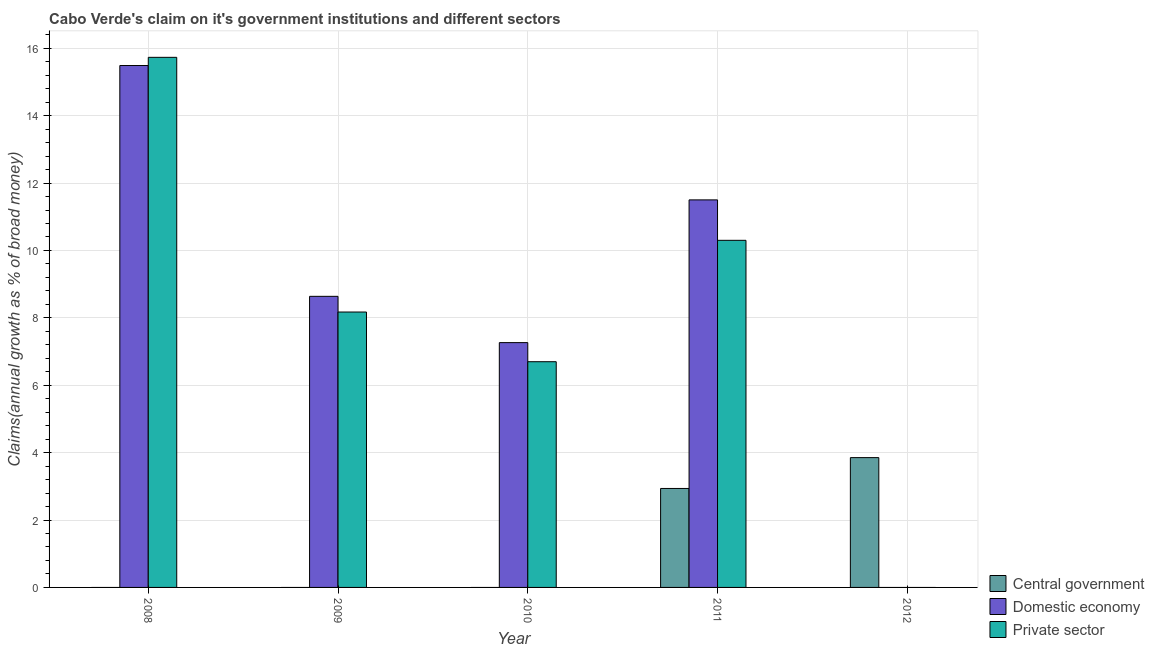Are the number of bars on each tick of the X-axis equal?
Offer a terse response. No. What is the label of the 5th group of bars from the left?
Offer a very short reply. 2012. In how many cases, is the number of bars for a given year not equal to the number of legend labels?
Provide a succinct answer. 4. Across all years, what is the maximum percentage of claim on the central government?
Your answer should be very brief. 3.85. What is the total percentage of claim on the domestic economy in the graph?
Your answer should be compact. 42.89. What is the difference between the percentage of claim on the domestic economy in 2008 and that in 2009?
Your answer should be compact. 6.85. What is the difference between the percentage of claim on the domestic economy in 2010 and the percentage of claim on the private sector in 2008?
Your response must be concise. -8.22. What is the average percentage of claim on the private sector per year?
Give a very brief answer. 8.18. In the year 2008, what is the difference between the percentage of claim on the domestic economy and percentage of claim on the central government?
Offer a terse response. 0. In how many years, is the percentage of claim on the central government greater than 12 %?
Your answer should be compact. 0. Is the percentage of claim on the private sector in 2008 less than that in 2010?
Provide a short and direct response. No. Is the difference between the percentage of claim on the private sector in 2009 and 2011 greater than the difference between the percentage of claim on the central government in 2009 and 2011?
Your response must be concise. No. What is the difference between the highest and the second highest percentage of claim on the private sector?
Offer a terse response. 5.43. What is the difference between the highest and the lowest percentage of claim on the central government?
Offer a very short reply. 3.85. Is the sum of the percentage of claim on the domestic economy in 2009 and 2010 greater than the maximum percentage of claim on the private sector across all years?
Ensure brevity in your answer.  Yes. Is it the case that in every year, the sum of the percentage of claim on the central government and percentage of claim on the domestic economy is greater than the percentage of claim on the private sector?
Offer a terse response. No. Are all the bars in the graph horizontal?
Give a very brief answer. No. What is the difference between two consecutive major ticks on the Y-axis?
Offer a terse response. 2. Does the graph contain any zero values?
Provide a succinct answer. Yes. Does the graph contain grids?
Ensure brevity in your answer.  Yes. Where does the legend appear in the graph?
Offer a terse response. Bottom right. How many legend labels are there?
Keep it short and to the point. 3. What is the title of the graph?
Keep it short and to the point. Cabo Verde's claim on it's government institutions and different sectors. What is the label or title of the X-axis?
Your response must be concise. Year. What is the label or title of the Y-axis?
Keep it short and to the point. Claims(annual growth as % of broad money). What is the Claims(annual growth as % of broad money) in Central government in 2008?
Make the answer very short. 0. What is the Claims(annual growth as % of broad money) of Domestic economy in 2008?
Keep it short and to the point. 15.49. What is the Claims(annual growth as % of broad money) in Private sector in 2008?
Keep it short and to the point. 15.73. What is the Claims(annual growth as % of broad money) in Central government in 2009?
Provide a succinct answer. 0. What is the Claims(annual growth as % of broad money) in Domestic economy in 2009?
Make the answer very short. 8.64. What is the Claims(annual growth as % of broad money) in Private sector in 2009?
Ensure brevity in your answer.  8.17. What is the Claims(annual growth as % of broad money) of Domestic economy in 2010?
Provide a short and direct response. 7.26. What is the Claims(annual growth as % of broad money) of Private sector in 2010?
Your response must be concise. 6.7. What is the Claims(annual growth as % of broad money) in Central government in 2011?
Make the answer very short. 2.94. What is the Claims(annual growth as % of broad money) of Domestic economy in 2011?
Make the answer very short. 11.5. What is the Claims(annual growth as % of broad money) in Private sector in 2011?
Offer a very short reply. 10.3. What is the Claims(annual growth as % of broad money) of Central government in 2012?
Your answer should be compact. 3.85. What is the Claims(annual growth as % of broad money) of Domestic economy in 2012?
Your response must be concise. 0. Across all years, what is the maximum Claims(annual growth as % of broad money) in Central government?
Your answer should be compact. 3.85. Across all years, what is the maximum Claims(annual growth as % of broad money) in Domestic economy?
Provide a succinct answer. 15.49. Across all years, what is the maximum Claims(annual growth as % of broad money) in Private sector?
Offer a very short reply. 15.73. Across all years, what is the minimum Claims(annual growth as % of broad money) in Domestic economy?
Ensure brevity in your answer.  0. What is the total Claims(annual growth as % of broad money) in Central government in the graph?
Your response must be concise. 6.79. What is the total Claims(annual growth as % of broad money) in Domestic economy in the graph?
Give a very brief answer. 42.89. What is the total Claims(annual growth as % of broad money) in Private sector in the graph?
Your answer should be very brief. 40.9. What is the difference between the Claims(annual growth as % of broad money) of Domestic economy in 2008 and that in 2009?
Offer a terse response. 6.85. What is the difference between the Claims(annual growth as % of broad money) in Private sector in 2008 and that in 2009?
Provide a succinct answer. 7.56. What is the difference between the Claims(annual growth as % of broad money) of Domestic economy in 2008 and that in 2010?
Offer a very short reply. 8.22. What is the difference between the Claims(annual growth as % of broad money) of Private sector in 2008 and that in 2010?
Your answer should be very brief. 9.03. What is the difference between the Claims(annual growth as % of broad money) of Domestic economy in 2008 and that in 2011?
Provide a short and direct response. 3.99. What is the difference between the Claims(annual growth as % of broad money) in Private sector in 2008 and that in 2011?
Provide a succinct answer. 5.43. What is the difference between the Claims(annual growth as % of broad money) of Domestic economy in 2009 and that in 2010?
Give a very brief answer. 1.37. What is the difference between the Claims(annual growth as % of broad money) of Private sector in 2009 and that in 2010?
Offer a very short reply. 1.47. What is the difference between the Claims(annual growth as % of broad money) of Domestic economy in 2009 and that in 2011?
Ensure brevity in your answer.  -2.86. What is the difference between the Claims(annual growth as % of broad money) in Private sector in 2009 and that in 2011?
Provide a succinct answer. -2.13. What is the difference between the Claims(annual growth as % of broad money) in Domestic economy in 2010 and that in 2011?
Provide a short and direct response. -4.24. What is the difference between the Claims(annual growth as % of broad money) of Private sector in 2010 and that in 2011?
Your response must be concise. -3.6. What is the difference between the Claims(annual growth as % of broad money) of Central government in 2011 and that in 2012?
Give a very brief answer. -0.92. What is the difference between the Claims(annual growth as % of broad money) of Domestic economy in 2008 and the Claims(annual growth as % of broad money) of Private sector in 2009?
Offer a terse response. 7.31. What is the difference between the Claims(annual growth as % of broad money) of Domestic economy in 2008 and the Claims(annual growth as % of broad money) of Private sector in 2010?
Provide a short and direct response. 8.79. What is the difference between the Claims(annual growth as % of broad money) in Domestic economy in 2008 and the Claims(annual growth as % of broad money) in Private sector in 2011?
Ensure brevity in your answer.  5.19. What is the difference between the Claims(annual growth as % of broad money) of Domestic economy in 2009 and the Claims(annual growth as % of broad money) of Private sector in 2010?
Your answer should be very brief. 1.94. What is the difference between the Claims(annual growth as % of broad money) of Domestic economy in 2009 and the Claims(annual growth as % of broad money) of Private sector in 2011?
Ensure brevity in your answer.  -1.66. What is the difference between the Claims(annual growth as % of broad money) of Domestic economy in 2010 and the Claims(annual growth as % of broad money) of Private sector in 2011?
Your answer should be very brief. -3.04. What is the average Claims(annual growth as % of broad money) of Central government per year?
Offer a terse response. 1.36. What is the average Claims(annual growth as % of broad money) of Domestic economy per year?
Your answer should be very brief. 8.58. What is the average Claims(annual growth as % of broad money) of Private sector per year?
Offer a very short reply. 8.18. In the year 2008, what is the difference between the Claims(annual growth as % of broad money) of Domestic economy and Claims(annual growth as % of broad money) of Private sector?
Offer a terse response. -0.24. In the year 2009, what is the difference between the Claims(annual growth as % of broad money) of Domestic economy and Claims(annual growth as % of broad money) of Private sector?
Ensure brevity in your answer.  0.47. In the year 2010, what is the difference between the Claims(annual growth as % of broad money) in Domestic economy and Claims(annual growth as % of broad money) in Private sector?
Make the answer very short. 0.57. In the year 2011, what is the difference between the Claims(annual growth as % of broad money) of Central government and Claims(annual growth as % of broad money) of Domestic economy?
Make the answer very short. -8.56. In the year 2011, what is the difference between the Claims(annual growth as % of broad money) in Central government and Claims(annual growth as % of broad money) in Private sector?
Make the answer very short. -7.36. In the year 2011, what is the difference between the Claims(annual growth as % of broad money) in Domestic economy and Claims(annual growth as % of broad money) in Private sector?
Offer a terse response. 1.2. What is the ratio of the Claims(annual growth as % of broad money) of Domestic economy in 2008 to that in 2009?
Give a very brief answer. 1.79. What is the ratio of the Claims(annual growth as % of broad money) in Private sector in 2008 to that in 2009?
Offer a terse response. 1.92. What is the ratio of the Claims(annual growth as % of broad money) of Domestic economy in 2008 to that in 2010?
Your answer should be compact. 2.13. What is the ratio of the Claims(annual growth as % of broad money) of Private sector in 2008 to that in 2010?
Provide a succinct answer. 2.35. What is the ratio of the Claims(annual growth as % of broad money) of Domestic economy in 2008 to that in 2011?
Offer a terse response. 1.35. What is the ratio of the Claims(annual growth as % of broad money) in Private sector in 2008 to that in 2011?
Provide a short and direct response. 1.53. What is the ratio of the Claims(annual growth as % of broad money) in Domestic economy in 2009 to that in 2010?
Provide a short and direct response. 1.19. What is the ratio of the Claims(annual growth as % of broad money) in Private sector in 2009 to that in 2010?
Provide a succinct answer. 1.22. What is the ratio of the Claims(annual growth as % of broad money) in Domestic economy in 2009 to that in 2011?
Make the answer very short. 0.75. What is the ratio of the Claims(annual growth as % of broad money) of Private sector in 2009 to that in 2011?
Offer a terse response. 0.79. What is the ratio of the Claims(annual growth as % of broad money) of Domestic economy in 2010 to that in 2011?
Give a very brief answer. 0.63. What is the ratio of the Claims(annual growth as % of broad money) of Private sector in 2010 to that in 2011?
Ensure brevity in your answer.  0.65. What is the ratio of the Claims(annual growth as % of broad money) in Central government in 2011 to that in 2012?
Offer a terse response. 0.76. What is the difference between the highest and the second highest Claims(annual growth as % of broad money) of Domestic economy?
Offer a very short reply. 3.99. What is the difference between the highest and the second highest Claims(annual growth as % of broad money) of Private sector?
Make the answer very short. 5.43. What is the difference between the highest and the lowest Claims(annual growth as % of broad money) in Central government?
Give a very brief answer. 3.85. What is the difference between the highest and the lowest Claims(annual growth as % of broad money) in Domestic economy?
Provide a succinct answer. 15.49. What is the difference between the highest and the lowest Claims(annual growth as % of broad money) in Private sector?
Keep it short and to the point. 15.73. 